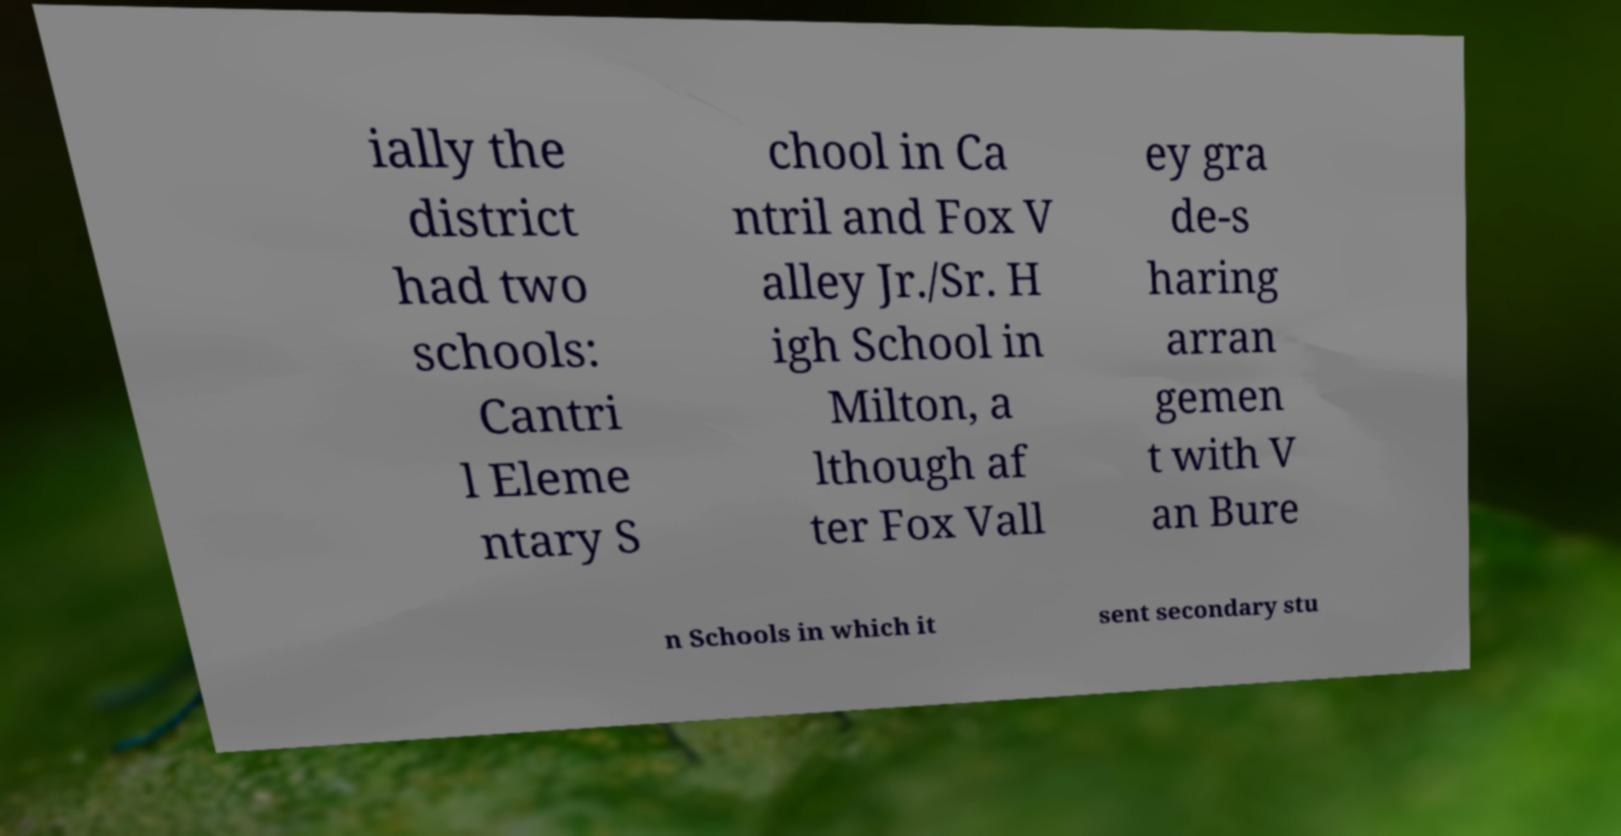Can you accurately transcribe the text from the provided image for me? ially the district had two schools: Cantri l Eleme ntary S chool in Ca ntril and Fox V alley Jr./Sr. H igh School in Milton, a lthough af ter Fox Vall ey gra de-s haring arran gemen t with V an Bure n Schools in which it sent secondary stu 